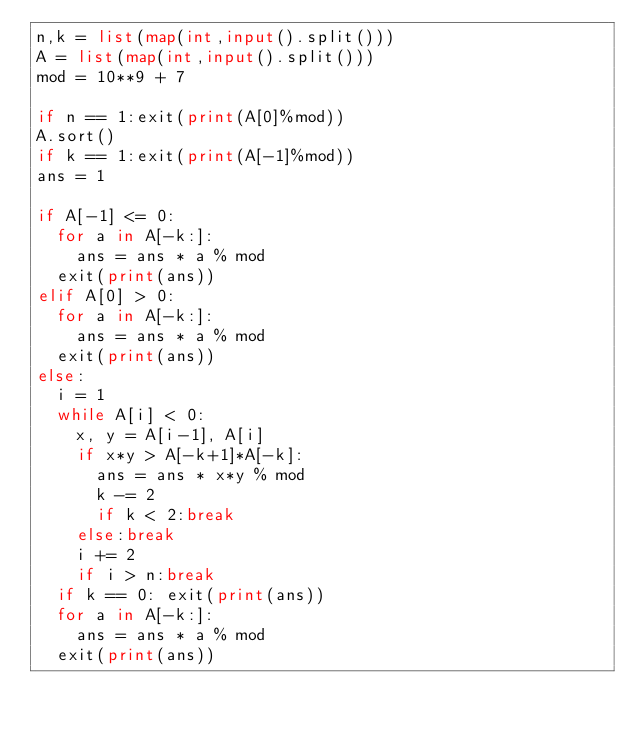<code> <loc_0><loc_0><loc_500><loc_500><_Python_>n,k = list(map(int,input().split()))
A = list(map(int,input().split()))
mod = 10**9 + 7

if n == 1:exit(print(A[0]%mod))
A.sort()
if k == 1:exit(print(A[-1]%mod))
ans = 1

if A[-1] <= 0:
  for a in A[-k:]:
    ans = ans * a % mod
  exit(print(ans))
elif A[0] > 0:
  for a in A[-k:]:
    ans = ans * a % mod
  exit(print(ans))
else:
  i = 1
  while A[i] < 0:
    x, y = A[i-1], A[i]
    if x*y > A[-k+1]*A[-k]:
      ans = ans * x*y % mod
      k -= 2
      if k < 2:break
    else:break
    i += 2
    if i > n:break
  if k == 0: exit(print(ans))
  for a in A[-k:]:
    ans = ans * a % mod
  exit(print(ans))
</code> 